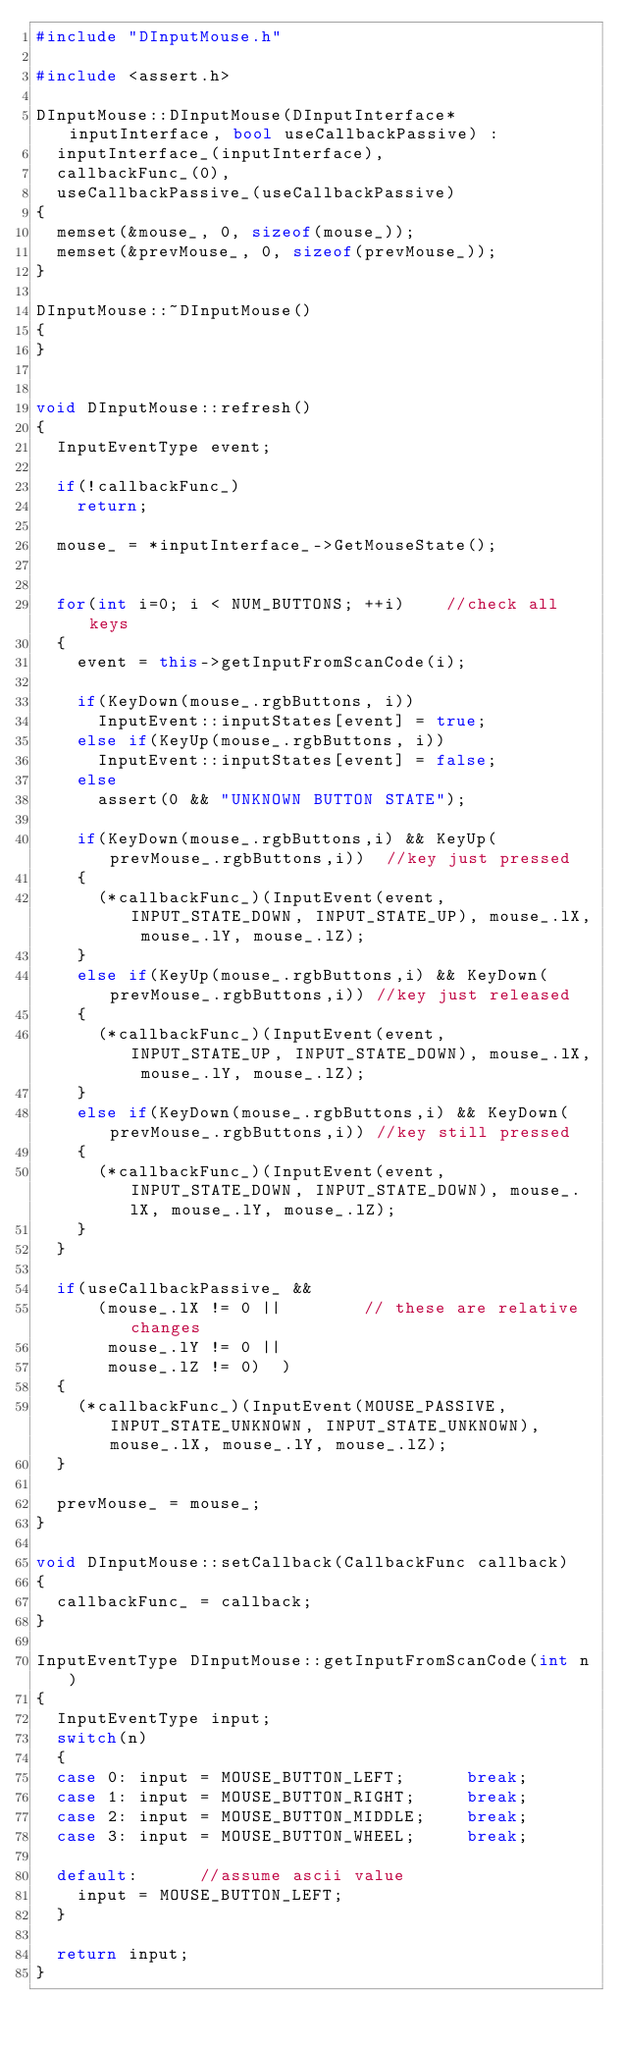Convert code to text. <code><loc_0><loc_0><loc_500><loc_500><_C++_>#include "DInputMouse.h"

#include <assert.h>

DInputMouse::DInputMouse(DInputInterface* inputInterface, bool useCallbackPassive) :
	inputInterface_(inputInterface),
	callbackFunc_(0),
	useCallbackPassive_(useCallbackPassive)
{
	memset(&mouse_, 0, sizeof(mouse_));
	memset(&prevMouse_, 0, sizeof(prevMouse_));
}

DInputMouse::~DInputMouse()
{
}


void DInputMouse::refresh()
{
	InputEventType event;

	if(!callbackFunc_)
		return;

	mouse_ = *inputInterface_->GetMouseState();

	
	for(int i=0; i < NUM_BUTTONS; ++i)		//check all keys
	{
		event = this->getInputFromScanCode(i);

		if(KeyDown(mouse_.rgbButtons, i))
			InputEvent::inputStates[event] = true;
		else if(KeyUp(mouse_.rgbButtons, i))
			InputEvent::inputStates[event] = false;		
		else
			assert(0 && "UNKNOWN BUTTON STATE");

		if(KeyDown(mouse_.rgbButtons,i) && KeyUp(prevMouse_.rgbButtons,i))	//key just pressed
		{
			(*callbackFunc_)(InputEvent(event, INPUT_STATE_DOWN, INPUT_STATE_UP), mouse_.lX, mouse_.lY, mouse_.lZ);	
		}
		else if(KeyUp(mouse_.rgbButtons,i) && KeyDown(prevMouse_.rgbButtons,i))	//key just released
		{
			(*callbackFunc_)(InputEvent(event, INPUT_STATE_UP, INPUT_STATE_DOWN), mouse_.lX, mouse_.lY, mouse_.lZ);	
		}
		else if(KeyDown(mouse_.rgbButtons,i) && KeyDown(prevMouse_.rgbButtons,i))	//key still pressed
		{
			(*callbackFunc_)(InputEvent(event, INPUT_STATE_DOWN, INPUT_STATE_DOWN), mouse_.lX, mouse_.lY, mouse_.lZ);	
		}		
	}

	if(useCallbackPassive_ && 
			(mouse_.lX != 0	||				// these are relative changes
			 mouse_.lY != 0 ||
			 mouse_.lZ != 0)	)
	{
		(*callbackFunc_)(InputEvent(MOUSE_PASSIVE, INPUT_STATE_UNKNOWN, INPUT_STATE_UNKNOWN), mouse_.lX, mouse_.lY, mouse_.lZ);	
	}

	prevMouse_ = mouse_;	
}

void DInputMouse::setCallback(CallbackFunc callback)
{
	callbackFunc_ = callback;
}

InputEventType DInputMouse::getInputFromScanCode(int n)
{
	InputEventType input;
	switch(n)
	{
	case 0:	input = MOUSE_BUTTON_LEFT;			break;
	case 1:	input = MOUSE_BUTTON_RIGHT;			break;
	case 2:	input = MOUSE_BUTTON_MIDDLE;		break;
	case 3:	input = MOUSE_BUTTON_WHEEL;			break;

	default:			//assume ascii value
		input = MOUSE_BUTTON_LEFT;
	}

	return input;
}</code> 